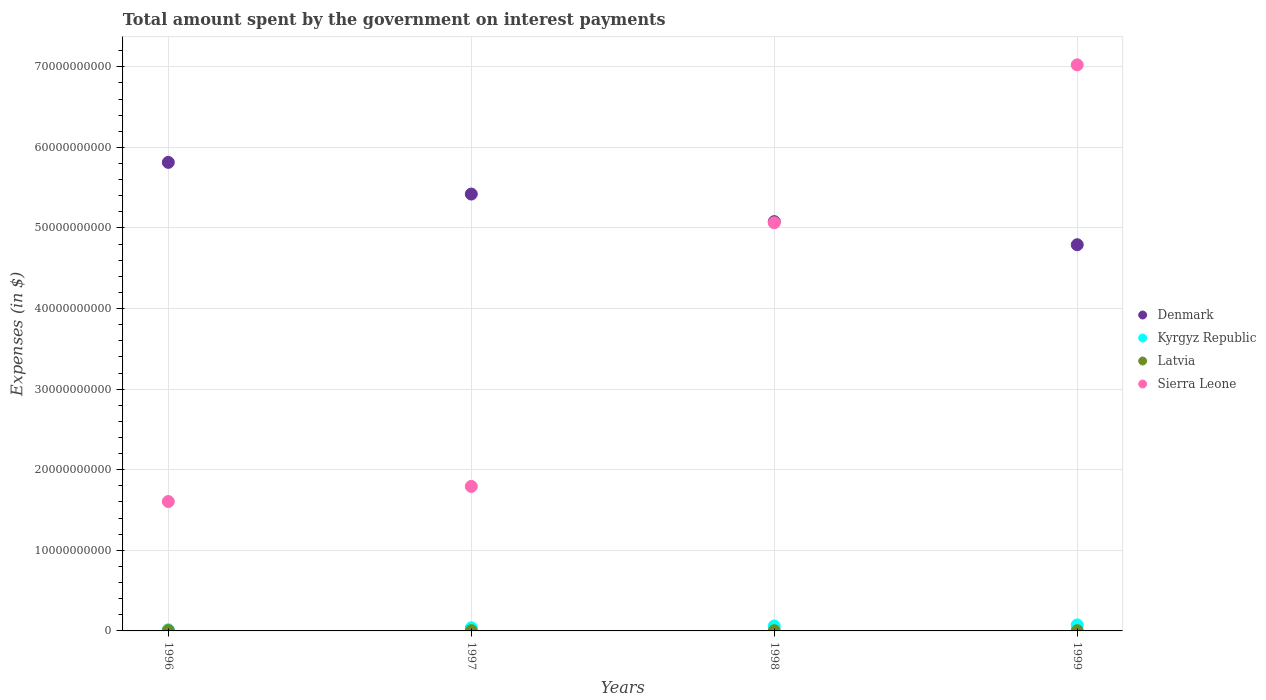How many different coloured dotlines are there?
Make the answer very short. 4. Is the number of dotlines equal to the number of legend labels?
Your answer should be very brief. Yes. What is the amount spent on interest payments by the government in Latvia in 1998?
Ensure brevity in your answer.  2.67e+07. Across all years, what is the maximum amount spent on interest payments by the government in Sierra Leone?
Offer a terse response. 7.02e+1. Across all years, what is the minimum amount spent on interest payments by the government in Latvia?
Your answer should be very brief. 2.67e+07. In which year was the amount spent on interest payments by the government in Denmark maximum?
Your answer should be compact. 1996. What is the total amount spent on interest payments by the government in Latvia in the graph?
Make the answer very short. 1.33e+08. What is the difference between the amount spent on interest payments by the government in Latvia in 1996 and that in 1997?
Offer a very short reply. 1.59e+07. What is the difference between the amount spent on interest payments by the government in Sierra Leone in 1998 and the amount spent on interest payments by the government in Latvia in 1997?
Provide a short and direct response. 5.06e+1. What is the average amount spent on interest payments by the government in Kyrgyz Republic per year?
Provide a short and direct response. 4.72e+08. In the year 1997, what is the difference between the amount spent on interest payments by the government in Sierra Leone and amount spent on interest payments by the government in Latvia?
Your response must be concise. 1.79e+1. What is the ratio of the amount spent on interest payments by the government in Kyrgyz Republic in 1996 to that in 1998?
Your answer should be very brief. 0.24. Is the difference between the amount spent on interest payments by the government in Sierra Leone in 1996 and 1997 greater than the difference between the amount spent on interest payments by the government in Latvia in 1996 and 1997?
Provide a short and direct response. No. What is the difference between the highest and the second highest amount spent on interest payments by the government in Kyrgyz Republic?
Keep it short and to the point. 1.32e+08. What is the difference between the highest and the lowest amount spent on interest payments by the government in Kyrgyz Republic?
Provide a short and direct response. 5.95e+08. Is the sum of the amount spent on interest payments by the government in Kyrgyz Republic in 1997 and 1999 greater than the maximum amount spent on interest payments by the government in Denmark across all years?
Ensure brevity in your answer.  No. Is the amount spent on interest payments by the government in Latvia strictly greater than the amount spent on interest payments by the government in Kyrgyz Republic over the years?
Offer a terse response. No. Is the amount spent on interest payments by the government in Denmark strictly less than the amount spent on interest payments by the government in Latvia over the years?
Your response must be concise. No. How many dotlines are there?
Provide a succinct answer. 4. What is the difference between two consecutive major ticks on the Y-axis?
Your response must be concise. 1.00e+1. Are the values on the major ticks of Y-axis written in scientific E-notation?
Give a very brief answer. No. Does the graph contain any zero values?
Offer a very short reply. No. Where does the legend appear in the graph?
Offer a terse response. Center right. How are the legend labels stacked?
Provide a short and direct response. Vertical. What is the title of the graph?
Your answer should be very brief. Total amount spent by the government on interest payments. Does "Serbia" appear as one of the legend labels in the graph?
Provide a short and direct response. No. What is the label or title of the X-axis?
Ensure brevity in your answer.  Years. What is the label or title of the Y-axis?
Give a very brief answer. Expenses (in $). What is the Expenses (in $) of Denmark in 1996?
Your answer should be compact. 5.81e+1. What is the Expenses (in $) of Kyrgyz Republic in 1996?
Offer a terse response. 1.48e+08. What is the Expenses (in $) of Latvia in 1996?
Offer a terse response. 4.70e+07. What is the Expenses (in $) in Sierra Leone in 1996?
Keep it short and to the point. 1.61e+1. What is the Expenses (in $) of Denmark in 1997?
Offer a very short reply. 5.42e+1. What is the Expenses (in $) in Kyrgyz Republic in 1997?
Offer a very short reply. 3.85e+08. What is the Expenses (in $) of Latvia in 1997?
Offer a very short reply. 3.11e+07. What is the Expenses (in $) in Sierra Leone in 1997?
Provide a short and direct response. 1.79e+1. What is the Expenses (in $) of Denmark in 1998?
Your answer should be compact. 5.08e+1. What is the Expenses (in $) in Kyrgyz Republic in 1998?
Your answer should be very brief. 6.11e+08. What is the Expenses (in $) of Latvia in 1998?
Provide a succinct answer. 2.67e+07. What is the Expenses (in $) of Sierra Leone in 1998?
Provide a short and direct response. 5.06e+1. What is the Expenses (in $) in Denmark in 1999?
Keep it short and to the point. 4.79e+1. What is the Expenses (in $) of Kyrgyz Republic in 1999?
Make the answer very short. 7.43e+08. What is the Expenses (in $) of Latvia in 1999?
Ensure brevity in your answer.  2.80e+07. What is the Expenses (in $) in Sierra Leone in 1999?
Keep it short and to the point. 7.02e+1. Across all years, what is the maximum Expenses (in $) of Denmark?
Offer a very short reply. 5.81e+1. Across all years, what is the maximum Expenses (in $) of Kyrgyz Republic?
Your answer should be very brief. 7.43e+08. Across all years, what is the maximum Expenses (in $) of Latvia?
Your answer should be compact. 4.70e+07. Across all years, what is the maximum Expenses (in $) in Sierra Leone?
Give a very brief answer. 7.02e+1. Across all years, what is the minimum Expenses (in $) of Denmark?
Provide a short and direct response. 4.79e+1. Across all years, what is the minimum Expenses (in $) of Kyrgyz Republic?
Offer a terse response. 1.48e+08. Across all years, what is the minimum Expenses (in $) in Latvia?
Offer a terse response. 2.67e+07. Across all years, what is the minimum Expenses (in $) in Sierra Leone?
Provide a succinct answer. 1.61e+1. What is the total Expenses (in $) in Denmark in the graph?
Offer a very short reply. 2.11e+11. What is the total Expenses (in $) of Kyrgyz Republic in the graph?
Ensure brevity in your answer.  1.89e+09. What is the total Expenses (in $) in Latvia in the graph?
Your response must be concise. 1.33e+08. What is the total Expenses (in $) in Sierra Leone in the graph?
Offer a terse response. 1.55e+11. What is the difference between the Expenses (in $) in Denmark in 1996 and that in 1997?
Offer a terse response. 3.93e+09. What is the difference between the Expenses (in $) in Kyrgyz Republic in 1996 and that in 1997?
Provide a succinct answer. -2.37e+08. What is the difference between the Expenses (in $) in Latvia in 1996 and that in 1997?
Ensure brevity in your answer.  1.59e+07. What is the difference between the Expenses (in $) of Sierra Leone in 1996 and that in 1997?
Offer a very short reply. -1.88e+09. What is the difference between the Expenses (in $) in Denmark in 1996 and that in 1998?
Give a very brief answer. 7.35e+09. What is the difference between the Expenses (in $) of Kyrgyz Republic in 1996 and that in 1998?
Give a very brief answer. -4.63e+08. What is the difference between the Expenses (in $) of Latvia in 1996 and that in 1998?
Offer a terse response. 2.03e+07. What is the difference between the Expenses (in $) in Sierra Leone in 1996 and that in 1998?
Keep it short and to the point. -3.46e+1. What is the difference between the Expenses (in $) of Denmark in 1996 and that in 1999?
Give a very brief answer. 1.02e+1. What is the difference between the Expenses (in $) of Kyrgyz Republic in 1996 and that in 1999?
Provide a succinct answer. -5.95e+08. What is the difference between the Expenses (in $) of Latvia in 1996 and that in 1999?
Your answer should be very brief. 1.90e+07. What is the difference between the Expenses (in $) in Sierra Leone in 1996 and that in 1999?
Provide a succinct answer. -5.42e+1. What is the difference between the Expenses (in $) of Denmark in 1997 and that in 1998?
Give a very brief answer. 3.42e+09. What is the difference between the Expenses (in $) of Kyrgyz Republic in 1997 and that in 1998?
Make the answer very short. -2.26e+08. What is the difference between the Expenses (in $) of Latvia in 1997 and that in 1998?
Keep it short and to the point. 4.38e+06. What is the difference between the Expenses (in $) in Sierra Leone in 1997 and that in 1998?
Make the answer very short. -3.27e+1. What is the difference between the Expenses (in $) in Denmark in 1997 and that in 1999?
Make the answer very short. 6.29e+09. What is the difference between the Expenses (in $) in Kyrgyz Republic in 1997 and that in 1999?
Your answer should be compact. -3.58e+08. What is the difference between the Expenses (in $) in Latvia in 1997 and that in 1999?
Give a very brief answer. 3.17e+06. What is the difference between the Expenses (in $) in Sierra Leone in 1997 and that in 1999?
Provide a short and direct response. -5.23e+1. What is the difference between the Expenses (in $) of Denmark in 1998 and that in 1999?
Give a very brief answer. 2.86e+09. What is the difference between the Expenses (in $) of Kyrgyz Republic in 1998 and that in 1999?
Make the answer very short. -1.32e+08. What is the difference between the Expenses (in $) in Latvia in 1998 and that in 1999?
Provide a short and direct response. -1.21e+06. What is the difference between the Expenses (in $) of Sierra Leone in 1998 and that in 1999?
Your response must be concise. -1.96e+1. What is the difference between the Expenses (in $) in Denmark in 1996 and the Expenses (in $) in Kyrgyz Republic in 1997?
Make the answer very short. 5.78e+1. What is the difference between the Expenses (in $) of Denmark in 1996 and the Expenses (in $) of Latvia in 1997?
Ensure brevity in your answer.  5.81e+1. What is the difference between the Expenses (in $) of Denmark in 1996 and the Expenses (in $) of Sierra Leone in 1997?
Your answer should be very brief. 4.02e+1. What is the difference between the Expenses (in $) in Kyrgyz Republic in 1996 and the Expenses (in $) in Latvia in 1997?
Provide a succinct answer. 1.17e+08. What is the difference between the Expenses (in $) of Kyrgyz Republic in 1996 and the Expenses (in $) of Sierra Leone in 1997?
Offer a terse response. -1.78e+1. What is the difference between the Expenses (in $) of Latvia in 1996 and the Expenses (in $) of Sierra Leone in 1997?
Keep it short and to the point. -1.79e+1. What is the difference between the Expenses (in $) in Denmark in 1996 and the Expenses (in $) in Kyrgyz Republic in 1998?
Offer a terse response. 5.75e+1. What is the difference between the Expenses (in $) in Denmark in 1996 and the Expenses (in $) in Latvia in 1998?
Provide a succinct answer. 5.81e+1. What is the difference between the Expenses (in $) in Denmark in 1996 and the Expenses (in $) in Sierra Leone in 1998?
Offer a very short reply. 7.49e+09. What is the difference between the Expenses (in $) of Kyrgyz Republic in 1996 and the Expenses (in $) of Latvia in 1998?
Provide a succinct answer. 1.22e+08. What is the difference between the Expenses (in $) of Kyrgyz Republic in 1996 and the Expenses (in $) of Sierra Leone in 1998?
Give a very brief answer. -5.05e+1. What is the difference between the Expenses (in $) of Latvia in 1996 and the Expenses (in $) of Sierra Leone in 1998?
Provide a succinct answer. -5.06e+1. What is the difference between the Expenses (in $) of Denmark in 1996 and the Expenses (in $) of Kyrgyz Republic in 1999?
Give a very brief answer. 5.74e+1. What is the difference between the Expenses (in $) in Denmark in 1996 and the Expenses (in $) in Latvia in 1999?
Offer a terse response. 5.81e+1. What is the difference between the Expenses (in $) in Denmark in 1996 and the Expenses (in $) in Sierra Leone in 1999?
Your answer should be compact. -1.21e+1. What is the difference between the Expenses (in $) in Kyrgyz Republic in 1996 and the Expenses (in $) in Latvia in 1999?
Offer a terse response. 1.20e+08. What is the difference between the Expenses (in $) of Kyrgyz Republic in 1996 and the Expenses (in $) of Sierra Leone in 1999?
Provide a succinct answer. -7.01e+1. What is the difference between the Expenses (in $) of Latvia in 1996 and the Expenses (in $) of Sierra Leone in 1999?
Offer a very short reply. -7.02e+1. What is the difference between the Expenses (in $) of Denmark in 1997 and the Expenses (in $) of Kyrgyz Republic in 1998?
Keep it short and to the point. 5.36e+1. What is the difference between the Expenses (in $) of Denmark in 1997 and the Expenses (in $) of Latvia in 1998?
Give a very brief answer. 5.42e+1. What is the difference between the Expenses (in $) of Denmark in 1997 and the Expenses (in $) of Sierra Leone in 1998?
Offer a terse response. 3.56e+09. What is the difference between the Expenses (in $) of Kyrgyz Republic in 1997 and the Expenses (in $) of Latvia in 1998?
Your response must be concise. 3.59e+08. What is the difference between the Expenses (in $) of Kyrgyz Republic in 1997 and the Expenses (in $) of Sierra Leone in 1998?
Your answer should be compact. -5.03e+1. What is the difference between the Expenses (in $) of Latvia in 1997 and the Expenses (in $) of Sierra Leone in 1998?
Provide a succinct answer. -5.06e+1. What is the difference between the Expenses (in $) in Denmark in 1997 and the Expenses (in $) in Kyrgyz Republic in 1999?
Offer a terse response. 5.35e+1. What is the difference between the Expenses (in $) of Denmark in 1997 and the Expenses (in $) of Latvia in 1999?
Provide a short and direct response. 5.42e+1. What is the difference between the Expenses (in $) in Denmark in 1997 and the Expenses (in $) in Sierra Leone in 1999?
Your response must be concise. -1.60e+1. What is the difference between the Expenses (in $) in Kyrgyz Republic in 1997 and the Expenses (in $) in Latvia in 1999?
Your answer should be compact. 3.57e+08. What is the difference between the Expenses (in $) in Kyrgyz Republic in 1997 and the Expenses (in $) in Sierra Leone in 1999?
Offer a very short reply. -6.99e+1. What is the difference between the Expenses (in $) of Latvia in 1997 and the Expenses (in $) of Sierra Leone in 1999?
Provide a succinct answer. -7.02e+1. What is the difference between the Expenses (in $) of Denmark in 1998 and the Expenses (in $) of Kyrgyz Republic in 1999?
Provide a succinct answer. 5.00e+1. What is the difference between the Expenses (in $) of Denmark in 1998 and the Expenses (in $) of Latvia in 1999?
Offer a terse response. 5.08e+1. What is the difference between the Expenses (in $) in Denmark in 1998 and the Expenses (in $) in Sierra Leone in 1999?
Your answer should be compact. -1.95e+1. What is the difference between the Expenses (in $) of Kyrgyz Republic in 1998 and the Expenses (in $) of Latvia in 1999?
Make the answer very short. 5.83e+08. What is the difference between the Expenses (in $) in Kyrgyz Republic in 1998 and the Expenses (in $) in Sierra Leone in 1999?
Keep it short and to the point. -6.96e+1. What is the difference between the Expenses (in $) of Latvia in 1998 and the Expenses (in $) of Sierra Leone in 1999?
Provide a succinct answer. -7.02e+1. What is the average Expenses (in $) in Denmark per year?
Offer a very short reply. 5.28e+1. What is the average Expenses (in $) of Kyrgyz Republic per year?
Your answer should be compact. 4.72e+08. What is the average Expenses (in $) of Latvia per year?
Ensure brevity in your answer.  3.32e+07. What is the average Expenses (in $) of Sierra Leone per year?
Your answer should be compact. 3.87e+1. In the year 1996, what is the difference between the Expenses (in $) in Denmark and Expenses (in $) in Kyrgyz Republic?
Offer a terse response. 5.80e+1. In the year 1996, what is the difference between the Expenses (in $) of Denmark and Expenses (in $) of Latvia?
Offer a terse response. 5.81e+1. In the year 1996, what is the difference between the Expenses (in $) of Denmark and Expenses (in $) of Sierra Leone?
Your answer should be compact. 4.21e+1. In the year 1996, what is the difference between the Expenses (in $) in Kyrgyz Republic and Expenses (in $) in Latvia?
Give a very brief answer. 1.01e+08. In the year 1996, what is the difference between the Expenses (in $) of Kyrgyz Republic and Expenses (in $) of Sierra Leone?
Keep it short and to the point. -1.59e+1. In the year 1996, what is the difference between the Expenses (in $) in Latvia and Expenses (in $) in Sierra Leone?
Ensure brevity in your answer.  -1.60e+1. In the year 1997, what is the difference between the Expenses (in $) in Denmark and Expenses (in $) in Kyrgyz Republic?
Provide a succinct answer. 5.38e+1. In the year 1997, what is the difference between the Expenses (in $) of Denmark and Expenses (in $) of Latvia?
Your answer should be compact. 5.42e+1. In the year 1997, what is the difference between the Expenses (in $) in Denmark and Expenses (in $) in Sierra Leone?
Your answer should be very brief. 3.63e+1. In the year 1997, what is the difference between the Expenses (in $) of Kyrgyz Republic and Expenses (in $) of Latvia?
Keep it short and to the point. 3.54e+08. In the year 1997, what is the difference between the Expenses (in $) of Kyrgyz Republic and Expenses (in $) of Sierra Leone?
Offer a very short reply. -1.75e+1. In the year 1997, what is the difference between the Expenses (in $) in Latvia and Expenses (in $) in Sierra Leone?
Ensure brevity in your answer.  -1.79e+1. In the year 1998, what is the difference between the Expenses (in $) in Denmark and Expenses (in $) in Kyrgyz Republic?
Your response must be concise. 5.02e+1. In the year 1998, what is the difference between the Expenses (in $) of Denmark and Expenses (in $) of Latvia?
Your answer should be compact. 5.08e+1. In the year 1998, what is the difference between the Expenses (in $) in Denmark and Expenses (in $) in Sierra Leone?
Make the answer very short. 1.41e+08. In the year 1998, what is the difference between the Expenses (in $) in Kyrgyz Republic and Expenses (in $) in Latvia?
Provide a short and direct response. 5.85e+08. In the year 1998, what is the difference between the Expenses (in $) in Kyrgyz Republic and Expenses (in $) in Sierra Leone?
Give a very brief answer. -5.00e+1. In the year 1998, what is the difference between the Expenses (in $) in Latvia and Expenses (in $) in Sierra Leone?
Keep it short and to the point. -5.06e+1. In the year 1999, what is the difference between the Expenses (in $) of Denmark and Expenses (in $) of Kyrgyz Republic?
Offer a very short reply. 4.72e+1. In the year 1999, what is the difference between the Expenses (in $) in Denmark and Expenses (in $) in Latvia?
Make the answer very short. 4.79e+1. In the year 1999, what is the difference between the Expenses (in $) of Denmark and Expenses (in $) of Sierra Leone?
Give a very brief answer. -2.23e+1. In the year 1999, what is the difference between the Expenses (in $) in Kyrgyz Republic and Expenses (in $) in Latvia?
Keep it short and to the point. 7.15e+08. In the year 1999, what is the difference between the Expenses (in $) in Kyrgyz Republic and Expenses (in $) in Sierra Leone?
Provide a short and direct response. -6.95e+1. In the year 1999, what is the difference between the Expenses (in $) of Latvia and Expenses (in $) of Sierra Leone?
Provide a short and direct response. -7.02e+1. What is the ratio of the Expenses (in $) in Denmark in 1996 to that in 1997?
Ensure brevity in your answer.  1.07. What is the ratio of the Expenses (in $) of Kyrgyz Republic in 1996 to that in 1997?
Make the answer very short. 0.38. What is the ratio of the Expenses (in $) of Latvia in 1996 to that in 1997?
Your answer should be very brief. 1.51. What is the ratio of the Expenses (in $) of Sierra Leone in 1996 to that in 1997?
Give a very brief answer. 0.9. What is the ratio of the Expenses (in $) of Denmark in 1996 to that in 1998?
Offer a terse response. 1.14. What is the ratio of the Expenses (in $) of Kyrgyz Republic in 1996 to that in 1998?
Your answer should be compact. 0.24. What is the ratio of the Expenses (in $) of Latvia in 1996 to that in 1998?
Make the answer very short. 1.76. What is the ratio of the Expenses (in $) of Sierra Leone in 1996 to that in 1998?
Make the answer very short. 0.32. What is the ratio of the Expenses (in $) of Denmark in 1996 to that in 1999?
Give a very brief answer. 1.21. What is the ratio of the Expenses (in $) in Kyrgyz Republic in 1996 to that in 1999?
Make the answer very short. 0.2. What is the ratio of the Expenses (in $) of Latvia in 1996 to that in 1999?
Offer a very short reply. 1.68. What is the ratio of the Expenses (in $) of Sierra Leone in 1996 to that in 1999?
Offer a terse response. 0.23. What is the ratio of the Expenses (in $) of Denmark in 1997 to that in 1998?
Your answer should be very brief. 1.07. What is the ratio of the Expenses (in $) of Kyrgyz Republic in 1997 to that in 1998?
Offer a very short reply. 0.63. What is the ratio of the Expenses (in $) in Latvia in 1997 to that in 1998?
Provide a succinct answer. 1.16. What is the ratio of the Expenses (in $) in Sierra Leone in 1997 to that in 1998?
Offer a very short reply. 0.35. What is the ratio of the Expenses (in $) of Denmark in 1997 to that in 1999?
Your answer should be compact. 1.13. What is the ratio of the Expenses (in $) in Kyrgyz Republic in 1997 to that in 1999?
Provide a short and direct response. 0.52. What is the ratio of the Expenses (in $) of Latvia in 1997 to that in 1999?
Your response must be concise. 1.11. What is the ratio of the Expenses (in $) of Sierra Leone in 1997 to that in 1999?
Your answer should be compact. 0.26. What is the ratio of the Expenses (in $) of Denmark in 1998 to that in 1999?
Make the answer very short. 1.06. What is the ratio of the Expenses (in $) of Kyrgyz Republic in 1998 to that in 1999?
Your response must be concise. 0.82. What is the ratio of the Expenses (in $) of Latvia in 1998 to that in 1999?
Make the answer very short. 0.96. What is the ratio of the Expenses (in $) in Sierra Leone in 1998 to that in 1999?
Your answer should be compact. 0.72. What is the difference between the highest and the second highest Expenses (in $) of Denmark?
Provide a succinct answer. 3.93e+09. What is the difference between the highest and the second highest Expenses (in $) of Kyrgyz Republic?
Your answer should be very brief. 1.32e+08. What is the difference between the highest and the second highest Expenses (in $) in Latvia?
Offer a very short reply. 1.59e+07. What is the difference between the highest and the second highest Expenses (in $) of Sierra Leone?
Provide a short and direct response. 1.96e+1. What is the difference between the highest and the lowest Expenses (in $) in Denmark?
Ensure brevity in your answer.  1.02e+1. What is the difference between the highest and the lowest Expenses (in $) in Kyrgyz Republic?
Your answer should be compact. 5.95e+08. What is the difference between the highest and the lowest Expenses (in $) in Latvia?
Keep it short and to the point. 2.03e+07. What is the difference between the highest and the lowest Expenses (in $) of Sierra Leone?
Give a very brief answer. 5.42e+1. 